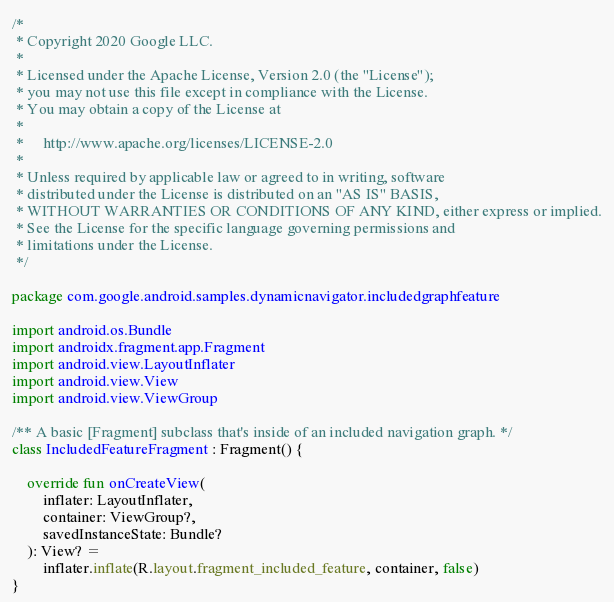<code> <loc_0><loc_0><loc_500><loc_500><_Kotlin_>/*
 * Copyright 2020 Google LLC.
 *
 * Licensed under the Apache License, Version 2.0 (the "License");
 * you may not use this file except in compliance with the License.
 * You may obtain a copy of the License at
 *
 *     http://www.apache.org/licenses/LICENSE-2.0
 *
 * Unless required by applicable law or agreed to in writing, software
 * distributed under the License is distributed on an "AS IS" BASIS,
 * WITHOUT WARRANTIES OR CONDITIONS OF ANY KIND, either express or implied.
 * See the License for the specific language governing permissions and
 * limitations under the License.
 */

package com.google.android.samples.dynamicnavigator.includedgraphfeature

import android.os.Bundle
import androidx.fragment.app.Fragment
import android.view.LayoutInflater
import android.view.View
import android.view.ViewGroup

/** A basic [Fragment] subclass that's inside of an included navigation graph. */
class IncludedFeatureFragment : Fragment() {

    override fun onCreateView(
        inflater: LayoutInflater,
        container: ViewGroup?,
        savedInstanceState: Bundle?
    ): View? =
        inflater.inflate(R.layout.fragment_included_feature, container, false)
}
</code> 